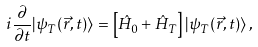Convert formula to latex. <formula><loc_0><loc_0><loc_500><loc_500>i \frac { \partial } { \partial t } | \psi _ { T } ( \vec { r } , t ) \rangle = \left [ \hat { H } _ { 0 } + \hat { H } _ { T } \right ] | \psi _ { T } ( \vec { r } , t ) \rangle \, ,</formula> 